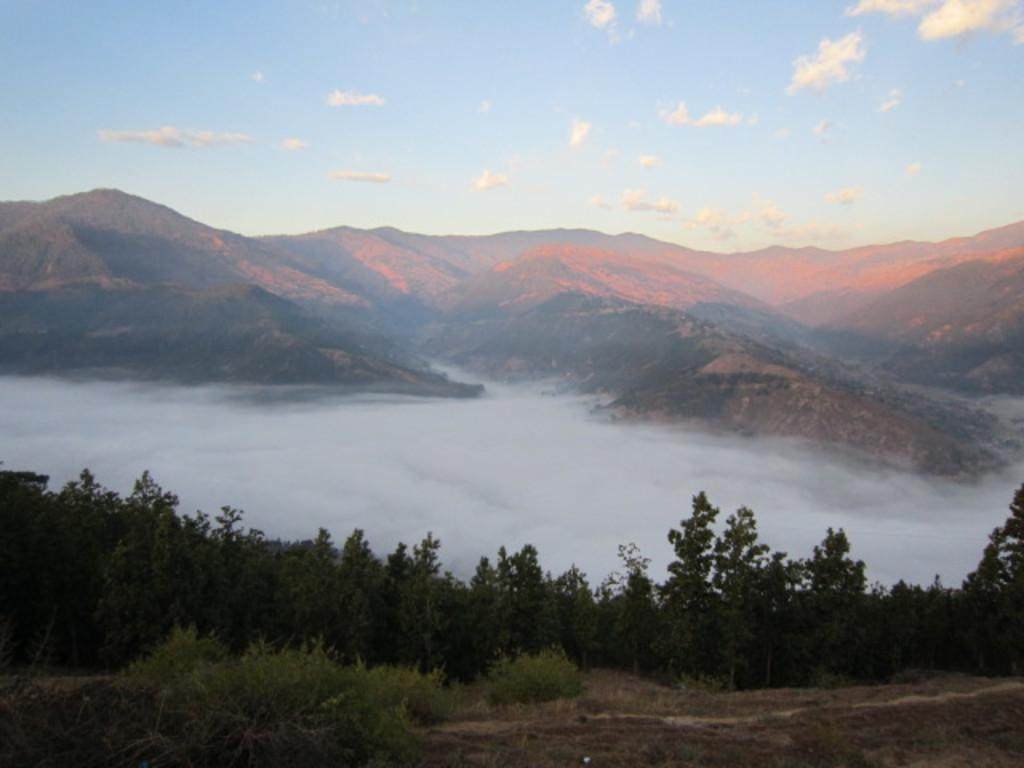What type of vegetation can be seen in the image? There are trees in the image. What atmospheric condition is present in the image? There is fog in the image. What type of landscape feature is visible in the image? There are hills in the image. What is visible in the background of the image? The sky is visible in the background of the image. What can be seen in the sky in the image? Clouds are present in the sky. Where is the map located in the image? There is no map present in the image. What type of musical instrument is being played in the image? There is no musical instrument or drum present in the image. 